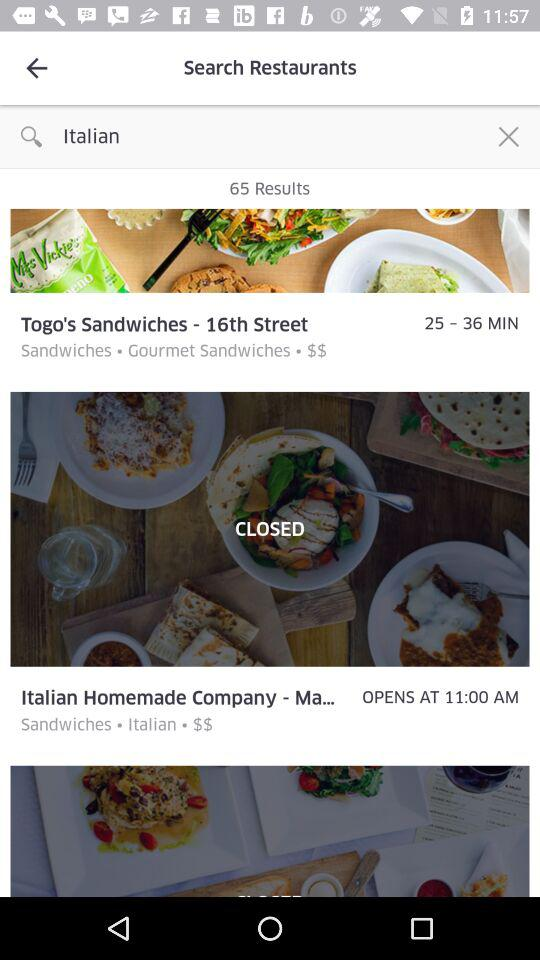At what time does the "Italian Homemade Company " open? The "Italian Homemade Company" opens at 11:00 a.m. 